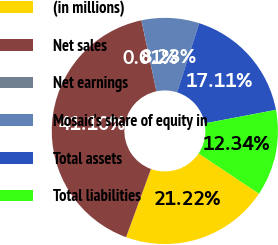Convert chart to OTSL. <chart><loc_0><loc_0><loc_500><loc_500><pie_chart><fcel>(in millions)<fcel>Net sales<fcel>Net earnings<fcel>Mosaic's share of equity in<fcel>Total assets<fcel>Total liabilities<nl><fcel>21.22%<fcel>41.11%<fcel>0.01%<fcel>8.23%<fcel>17.11%<fcel>12.34%<nl></chart> 